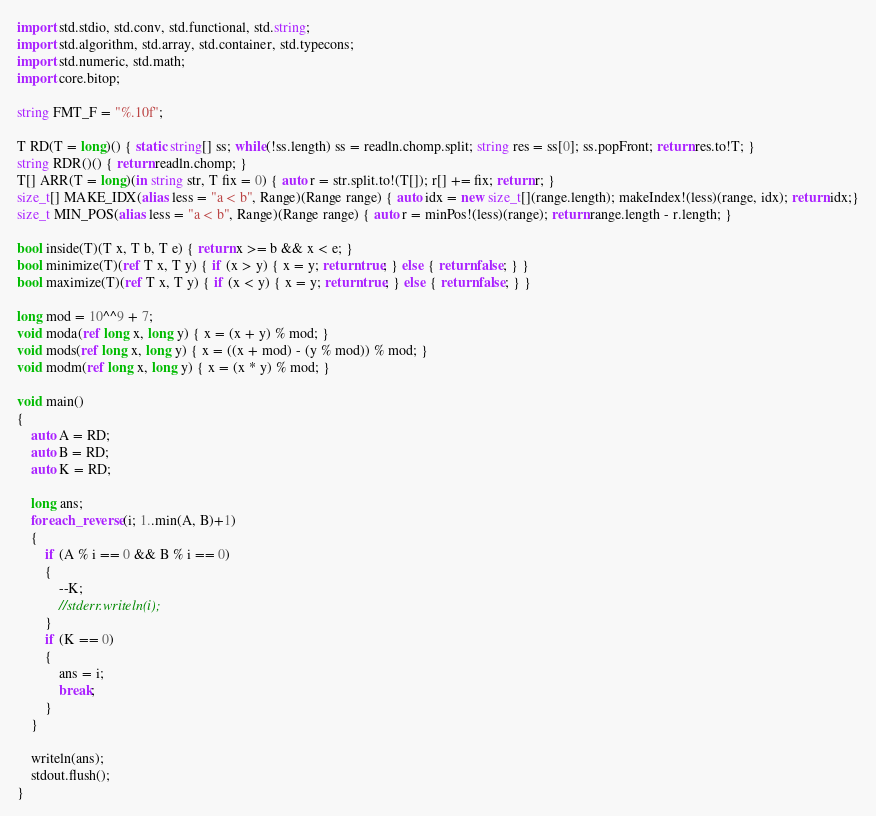Convert code to text. <code><loc_0><loc_0><loc_500><loc_500><_D_>import std.stdio, std.conv, std.functional, std.string;
import std.algorithm, std.array, std.container, std.typecons;
import std.numeric, std.math;
import core.bitop;

string FMT_F = "%.10f";

T RD(T = long)() { static string[] ss; while(!ss.length) ss = readln.chomp.split; string res = ss[0]; ss.popFront; return res.to!T; }
string RDR()() { return readln.chomp; }
T[] ARR(T = long)(in string str, T fix = 0) { auto r = str.split.to!(T[]); r[] += fix; return r; }
size_t[] MAKE_IDX(alias less = "a < b", Range)(Range range) { auto idx = new size_t[](range.length); makeIndex!(less)(range, idx); return idx;}
size_t MIN_POS(alias less = "a < b", Range)(Range range) { auto r = minPos!(less)(range); return range.length - r.length; }

bool inside(T)(T x, T b, T e) { return x >= b && x < e; }
bool minimize(T)(ref T x, T y) { if (x > y) { x = y; return true; } else { return false; } }
bool maximize(T)(ref T x, T y) { if (x < y) { x = y; return true; } else { return false; } }

long mod = 10^^9 + 7;
void moda(ref long x, long y) { x = (x + y) % mod; }
void mods(ref long x, long y) { x = ((x + mod) - (y % mod)) % mod; }
void modm(ref long x, long y) { x = (x * y) % mod; }

void main()
{
	auto A = RD;
	auto B = RD;
	auto K = RD;

	long ans;
	foreach_reverse (i; 1..min(A, B)+1)
	{
		if (A % i == 0 && B % i == 0) 
		{
			--K;
			//stderr.writeln(i);
		}
		if (K == 0)
		{
			ans = i;
			break;
		}
	}

	writeln(ans);
	stdout.flush();
}</code> 